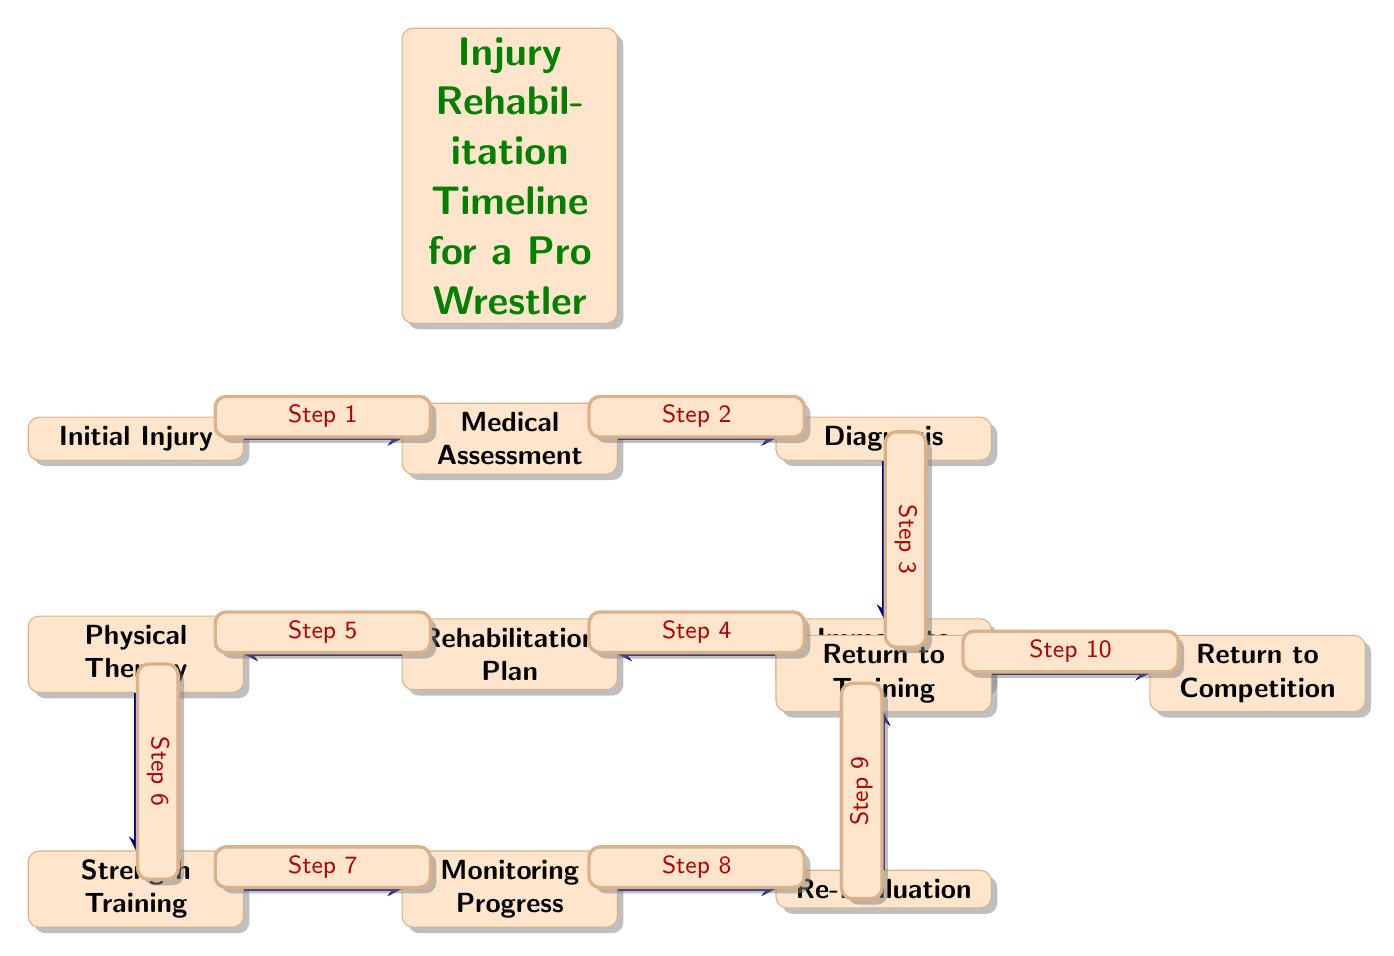What is the first step in the rehabilitation timeline? The first node in the diagram represents the initial event or stage, labeled "Initial Injury," which indicates the starting point of the injury rehabilitation process.
Answer: Initial Injury How many steps are there in the rehabilitation timeline? By counting all the nodes that represent steps from "Initial Injury" to "Return to Competition," we identify a total of 11 distinct steps in the timeline.
Answer: 11 Which step follows 'Diagnosis'? "Diagnosis" is directly followed by the node labeled "Immediate Treatment," which signifies the next action that takes place following the diagnosis of the injury.
Answer: Immediate Treatment What is the last step in the rehabilitation process? The last node in the sequence is "Return to Competition," indicating the final stage where the wrestler can return to competing after rehabilitation.
Answer: Return to Competition What is the relationship between 'Rehabilitation Plan' and 'Physical Therapy'? The "Rehabilitation Plan" node directly leads to the "Physical Therapy" node, meaning that physical therapy is part of or follows the rehabilitation plan created for the injured wrestler.
Answer: Directly leads to What is the role of 'Monitoring Progress' in the timeline? The node "Monitoring Progress" is positioned between "Strength Training" and "Re-Evaluation," implying it serves as a step where the athlete's recovery and performance are assessed before moving on to re-evaluation.
Answer: Assessment step What step occurs after 'Return to Training'? After the "Return to Training" node, the next step in the diagram is "Return to Competition," showing that training is a precursor to returning to competitive wrestling.
Answer: Return to Competition Which step comes before 'Strength Training'? The node labeled "Physical Therapy" precedes the "Strength Training" step in the timeline, indicating that physical therapy is undertaken before initiating strength training.
Answer: Physical Therapy What color is used for the nodes in the diagram? The diagram uses an orange color, as seen in the rectangles that represent the nodes, which visually distinguishes them against the background.
Answer: Orange 